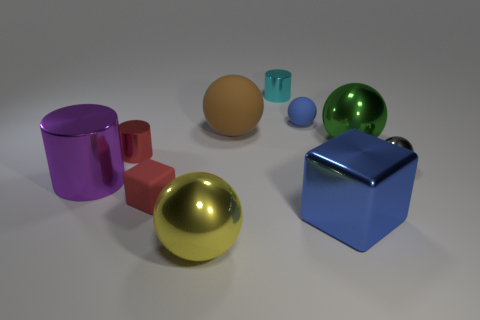Subtract all big cylinders. How many cylinders are left? 2 Subtract 1 cubes. How many cubes are left? 1 Subtract all cylinders. How many objects are left? 7 Subtract all gray balls. Subtract all yellow cubes. How many balls are left? 4 Subtract all purple spheres. How many gray blocks are left? 0 Subtract all purple metallic balls. Subtract all small cyan shiny objects. How many objects are left? 9 Add 9 large green shiny objects. How many large green shiny objects are left? 10 Add 2 small yellow metallic blocks. How many small yellow metallic blocks exist? 2 Subtract all purple cylinders. How many cylinders are left? 2 Subtract 0 red spheres. How many objects are left? 10 